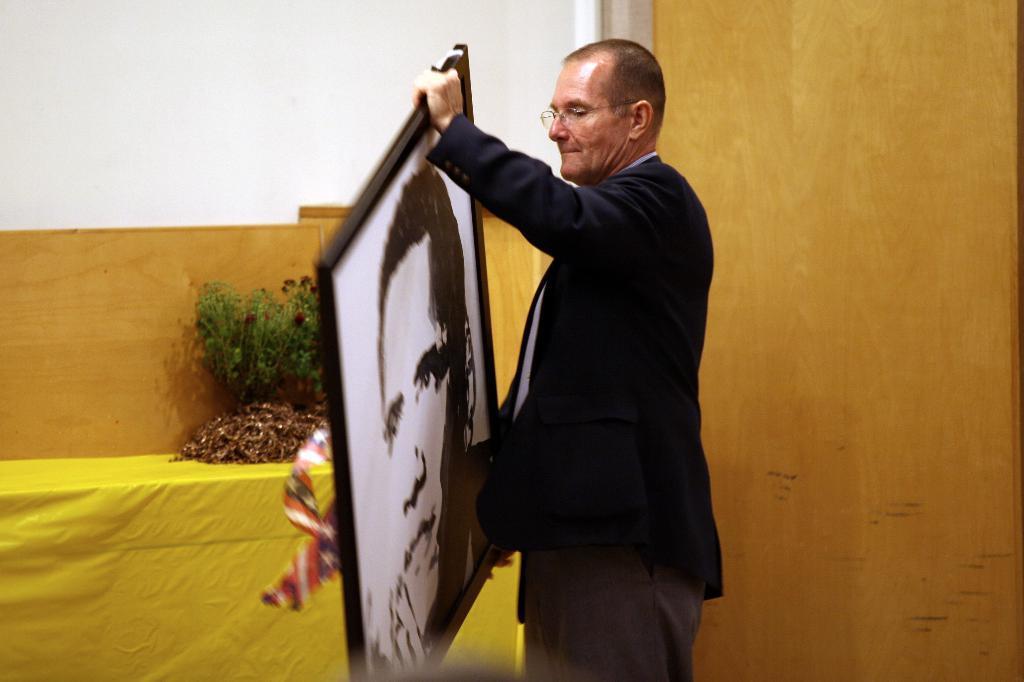Describe this image in one or two sentences. In this image in the center there is one man who is standing and he is holding a photo frame, in the background there is a wall and a table. On the table there are some plants. 